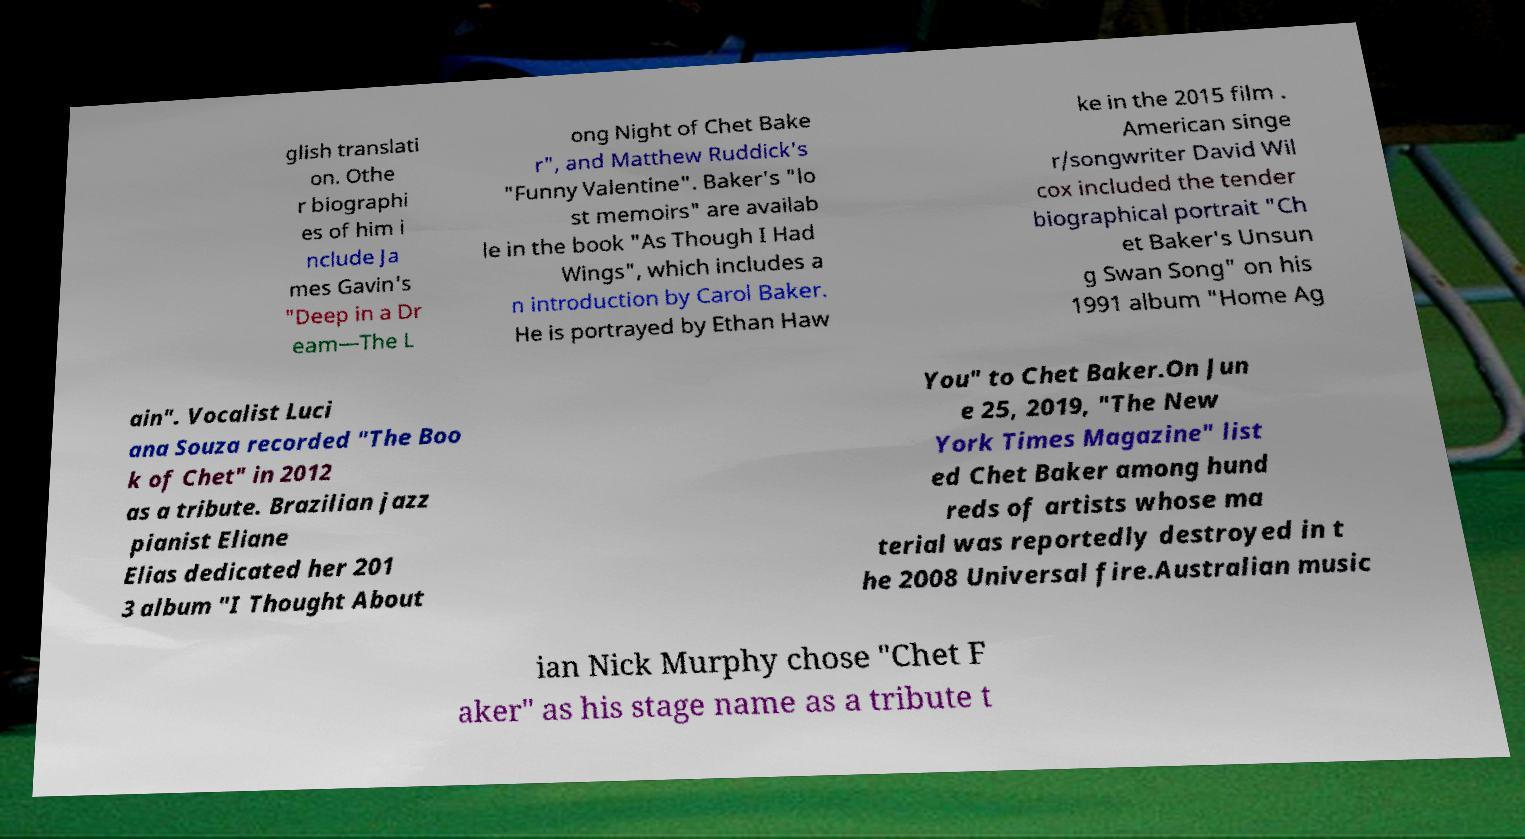What messages or text are displayed in this image? I need them in a readable, typed format. glish translati on. Othe r biographi es of him i nclude Ja mes Gavin's "Deep in a Dr eam—The L ong Night of Chet Bake r", and Matthew Ruddick's "Funny Valentine". Baker's "lo st memoirs" are availab le in the book "As Though I Had Wings", which includes a n introduction by Carol Baker. He is portrayed by Ethan Haw ke in the 2015 film . American singe r/songwriter David Wil cox included the tender biographical portrait "Ch et Baker's Unsun g Swan Song" on his 1991 album "Home Ag ain". Vocalist Luci ana Souza recorded "The Boo k of Chet" in 2012 as a tribute. Brazilian jazz pianist Eliane Elias dedicated her 201 3 album "I Thought About You" to Chet Baker.On Jun e 25, 2019, "The New York Times Magazine" list ed Chet Baker among hund reds of artists whose ma terial was reportedly destroyed in t he 2008 Universal fire.Australian music ian Nick Murphy chose "Chet F aker" as his stage name as a tribute t 